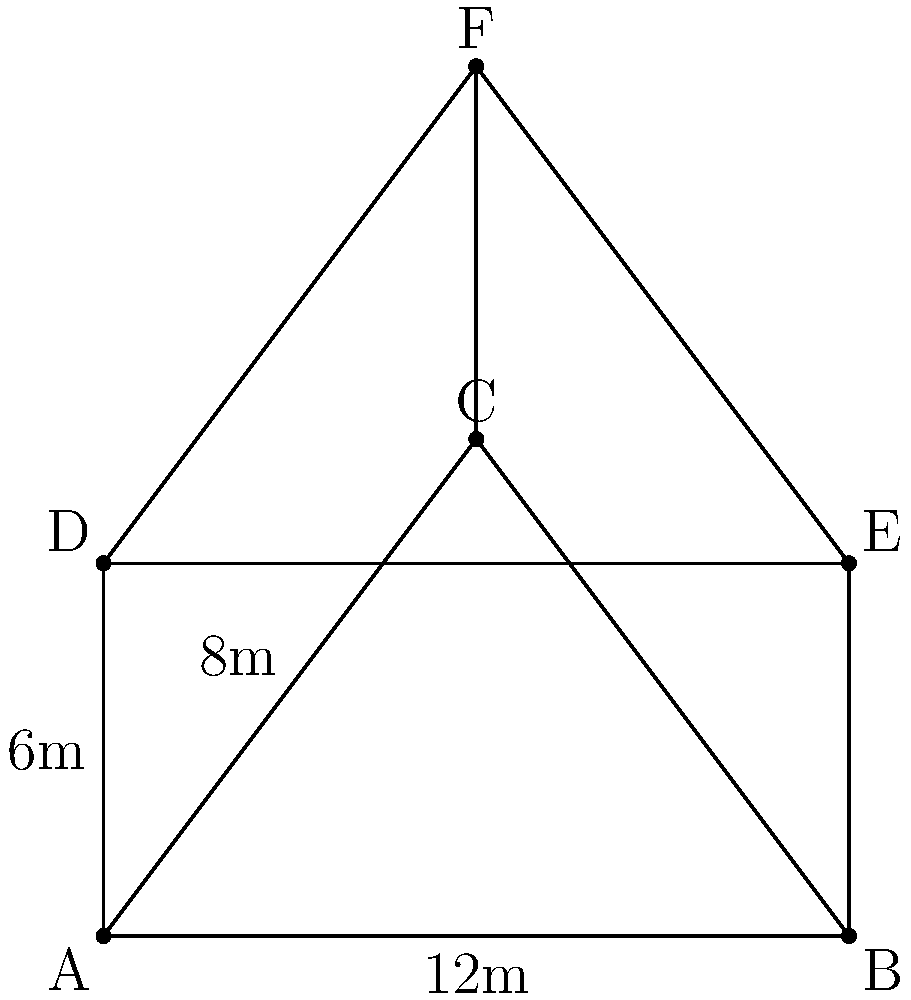As a public affairs officer for the 439th Airlift Wing, you need to estimate the cargo space in a triangular prism-shaped aircraft hold. The base of the hold is a right triangle with a base of 12 meters and a height of 8 meters. The length of the hold is 6 meters. What is the volume of this cargo hold in cubic meters? To find the volume of the triangular prism-shaped cargo hold, we need to follow these steps:

1. Calculate the area of the triangular base:
   The base is a right triangle with base $b = 12$ m and height $h = 8$ m.
   Area of a triangle = $\frac{1}{2} \times base \times height$
   $A = \frac{1}{2} \times 12 \times 8 = 48$ square meters

2. Use the volume formula for a prism:
   Volume of a prism = base area $\times$ length
   The length of the hold is $l = 6$ m

3. Calculate the volume:
   $V = A \times l$
   $V = 48 \times 6 = 288$ cubic meters

Therefore, the volume of the triangular prism-shaped aircraft hold is 288 cubic meters.
Answer: 288 cubic meters 